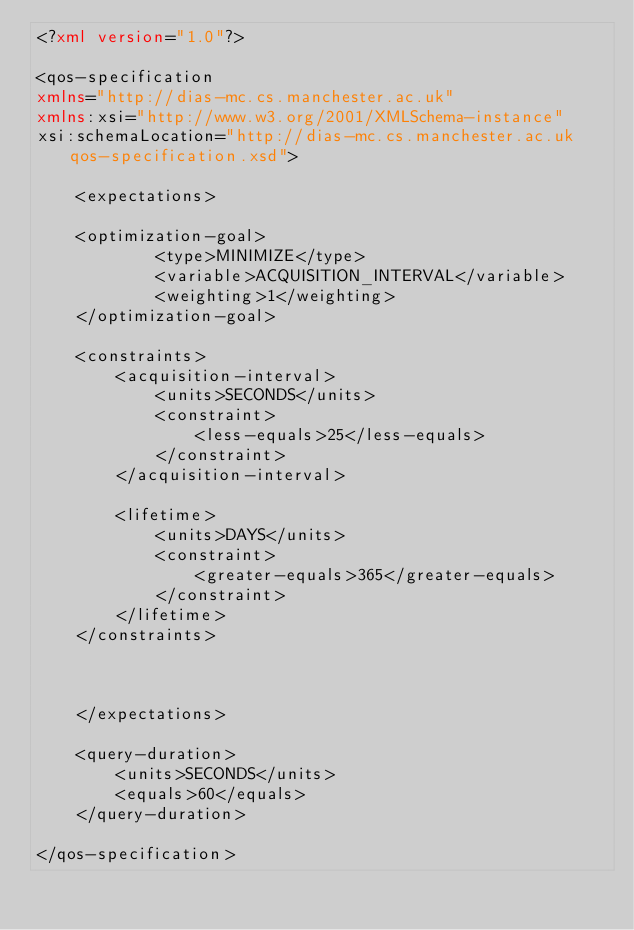Convert code to text. <code><loc_0><loc_0><loc_500><loc_500><_XML_><?xml version="1.0"?>

<qos-specification
xmlns="http://dias-mc.cs.manchester.ac.uk"
xmlns:xsi="http://www.w3.org/2001/XMLSchema-instance"
xsi:schemaLocation="http://dias-mc.cs.manchester.ac.uk qos-specification.xsd">

	<expectations>

	<optimization-goal>
			<type>MINIMIZE</type>
			<variable>ACQUISITION_INTERVAL</variable>
			<weighting>1</weighting>
	</optimization-goal>

	<constraints>
		<acquisition-interval>
			<units>SECONDS</units>
			<constraint>
				<less-equals>25</less-equals>
			</constraint>
		</acquisition-interval>	

		<lifetime>
			<units>DAYS</units>
			<constraint>
				<greater-equals>365</greater-equals>
			</constraint>
		</lifetime>
	</constraints>



	</expectations>
		
	<query-duration>
		<units>SECONDS</units>
		<equals>60</equals>
	</query-duration>
			
</qos-specification>	

</code> 